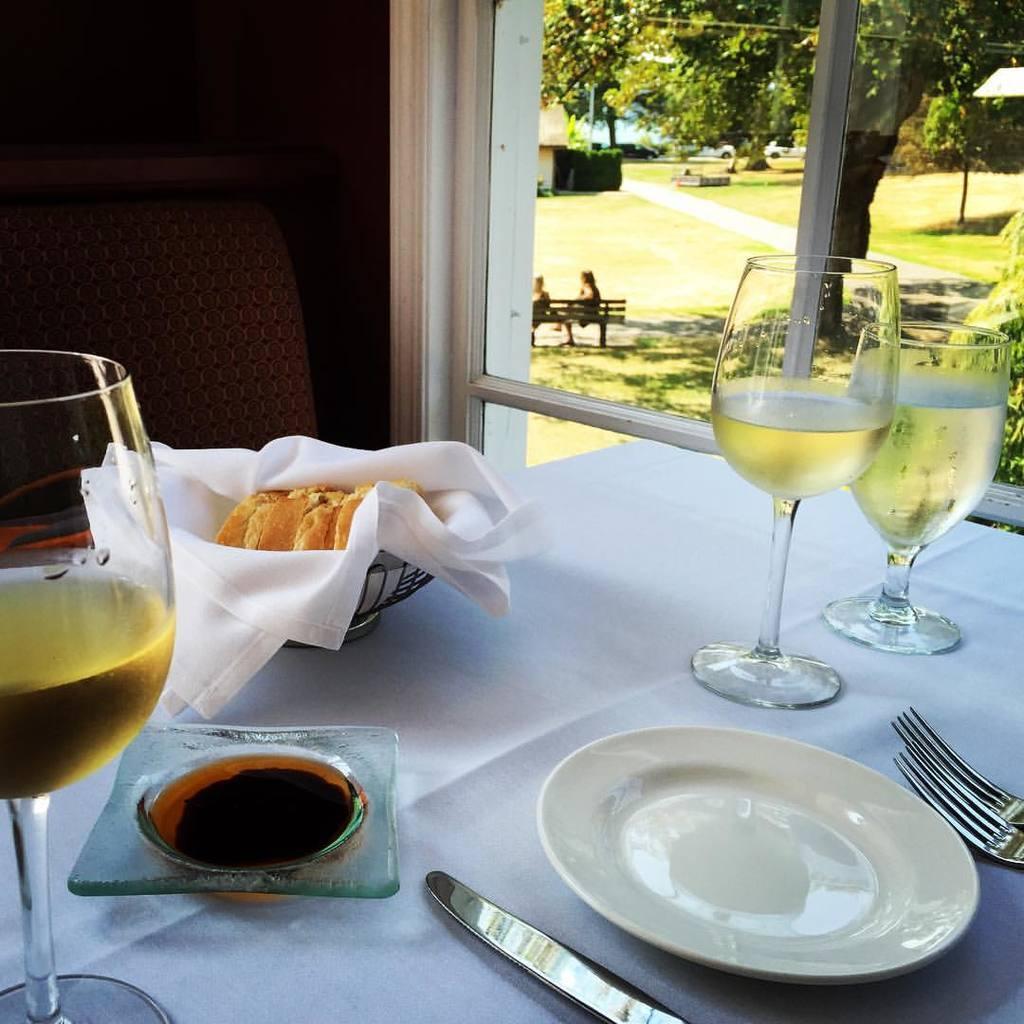In one or two sentences, can you explain what this image depicts? This picture is taken inside a room. in the foreground there is a table and chair. A cloth spread on the table. On the table there is bowl, plate, fork and wine glasses with wine in it. There is also a window on the wall. Through the window we can see there is a tree, house and a bench. There are people sitting on bench. 